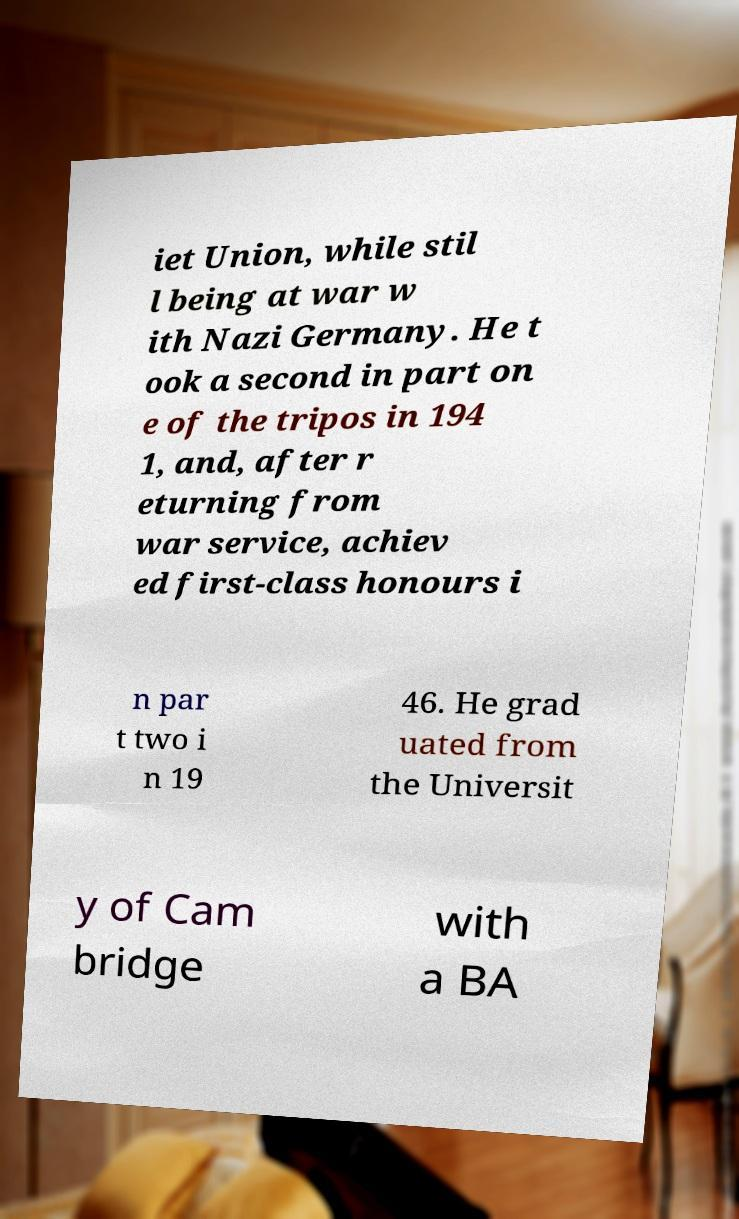Please read and relay the text visible in this image. What does it say? iet Union, while stil l being at war w ith Nazi Germany. He t ook a second in part on e of the tripos in 194 1, and, after r eturning from war service, achiev ed first-class honours i n par t two i n 19 46. He grad uated from the Universit y of Cam bridge with a BA 